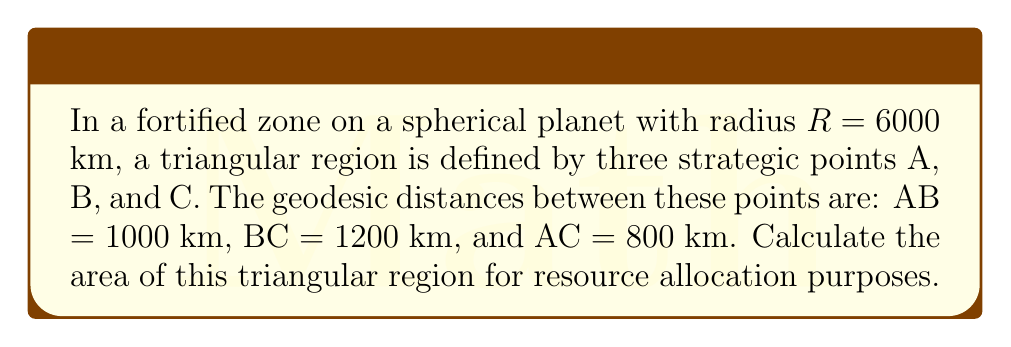Teach me how to tackle this problem. To solve this problem, we'll use the formula for the area of a spherical triangle:

$$A = R^2(α + β + γ - π)$$

where $A$ is the area, $R$ is the radius of the sphere, and $α$, $β$, and $γ$ are the angles of the spherical triangle in radians.

Step 1: Calculate the angles using the spherical law of cosines:
$$\cos(a) = \cos(b)\cos(c) + \sin(b)\sin(c)\cos(A)$$

Where $a$, $b$, and $c$ are the side lengths divided by the radius $R$.

For angle A:
$$\cos(A) = \frac{\cos(a) - \cos(b)\cos(c)}{\sin(b)\sin(c)}$$

$$a = \frac{1000}{6000} = \frac{1}{6}, b = \frac{1200}{6000} = \frac{1}{5}, c = \frac{800}{6000} = \frac{2}{15}$$

$$A = \arccos(\frac{\cos(\frac{1}{6}) - \cos(\frac{1}{5})\cos(\frac{2}{15})}{\sin(\frac{1}{5})\sin(\frac{2}{15})})$$

Step 2: Repeat for angles B and C.

Step 3: Sum the angles and subtract π:
$$S = A + B + C - π$$

Step 4: Calculate the area:
$$Area = R^2 \cdot S = 6000000^2 \cdot S$$

Step 5: Convert to square kilometers:
$$Area_{km^2} = \frac{Area}{1000000}$$
Answer: $Area_{km^2} = 36000000S$ km² 